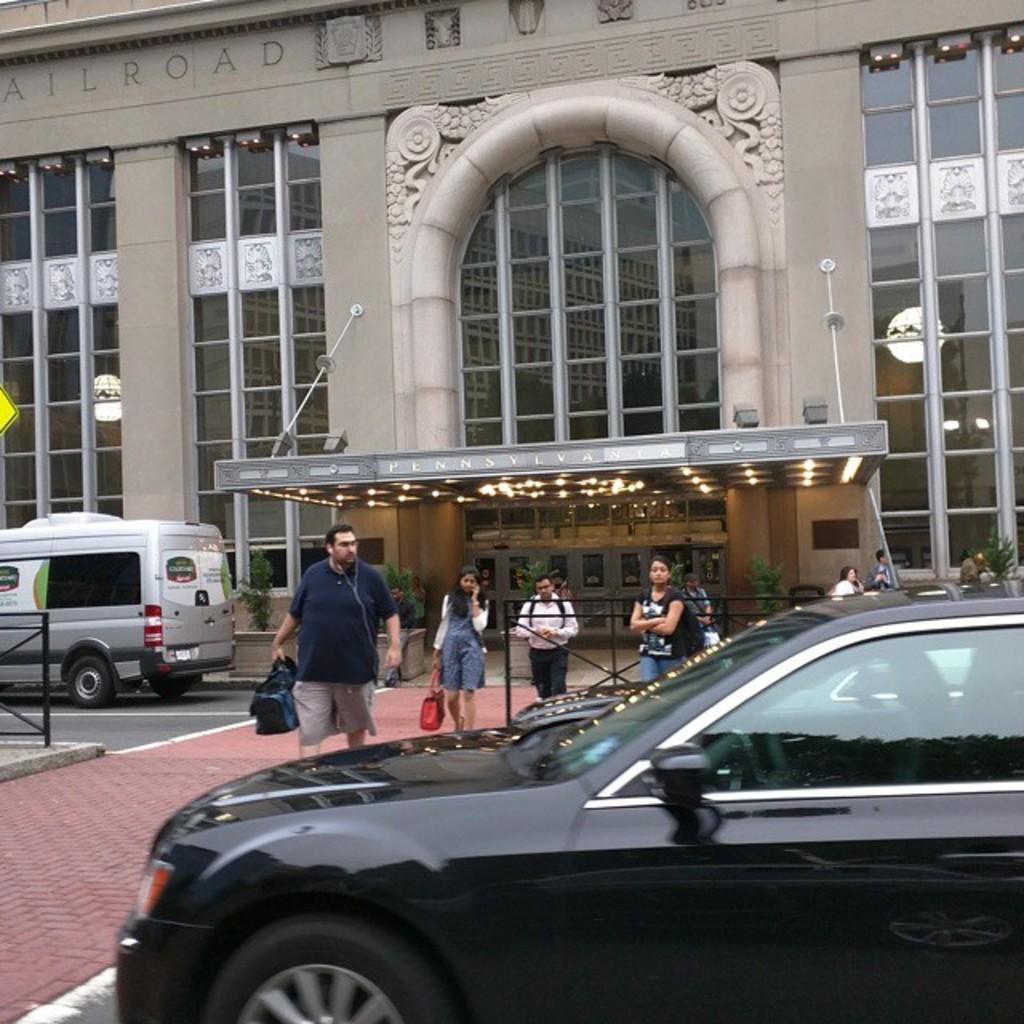In one or two sentences, can you explain what this image depicts? In this picture we can see people walking on the red path in front of a building with lights, glass windows and doors. There are vehicles on either side of the road. 